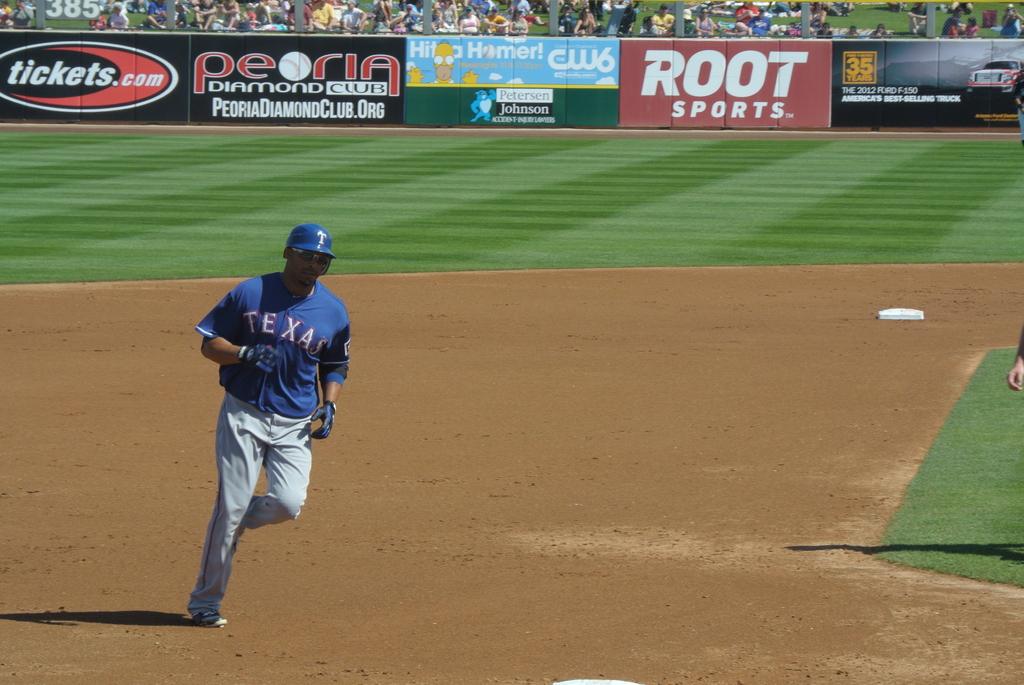What is the ticket website?
Keep it short and to the point. Tickets.com. What is the word on the guy's shirt?
Make the answer very short. Texas. 